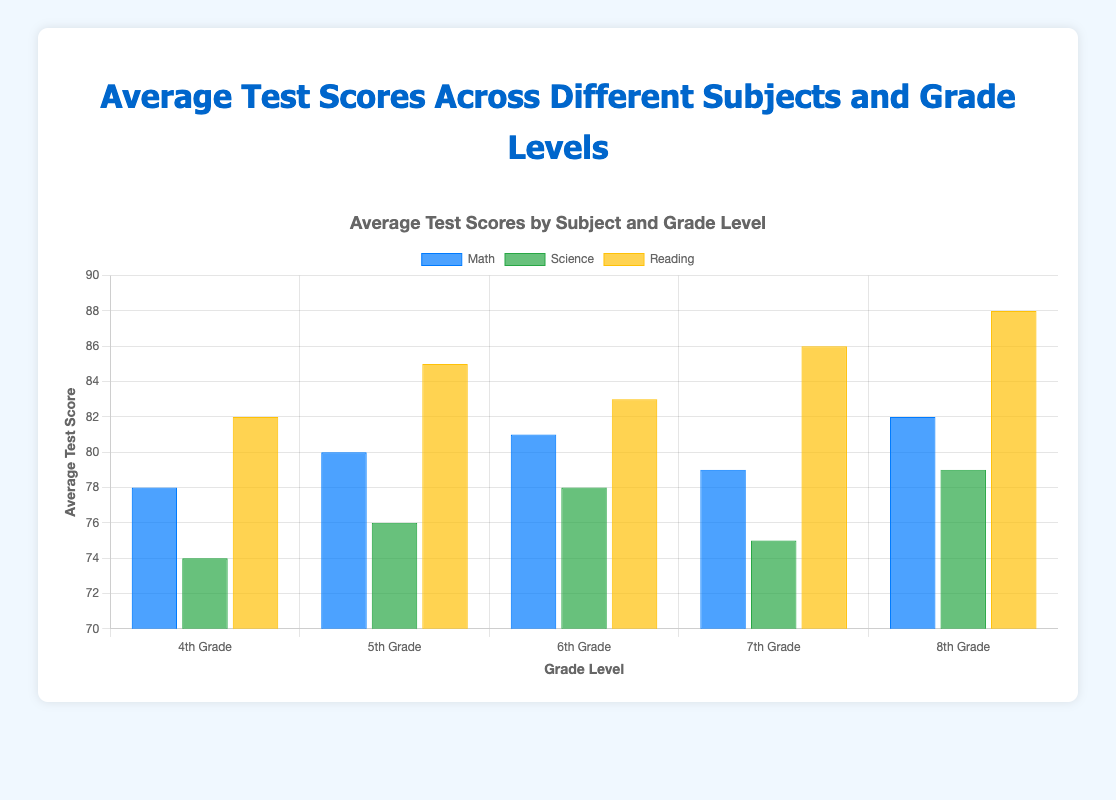What is the highest average test score for 8th Grade? To determine this, we look at the 8th Grade row and compare the scores across Math, Science, and Reading. The scores are Math: 82, Science: 79, and Reading: 88. Therefore, the highest score is from Reading.
Answer: 88 Which grade level has the highest average test score in Reading? To find the highest average test score in Reading, look at the Reading scores across all grades. The scores are 4th Grade: 82, 5th Grade: 85, 6th Grade: 83, 7th Grade: 86, and 8th Grade: 88. The highest score is in 8th Grade.
Answer: 8th Grade What is the difference between the average test scores in Math for 6th Grade and 7th Grade? We compare the Math scores for 6th Grade and 7th Grade. The Math score for 6th Grade is 81, and for 7th Grade it is 79. The difference is calculated as 81 - 79.
Answer: 2 How many grades show an average test score above 80 in Science? We examine the Science scores for each grade. The scores are 4th Grade: 74, 5th Grade: 76, 6th Grade: 78, 7th Grade: 75, and 8th Grade: 79. None of these scores are above 80.
Answer: 0 What is the average test score for Math across all grades? To find this, we sum the Math scores for all grades and divide by the number of grades. The scores are 4th Grade: 78, 5th Grade: 80, 6th Grade: 81, 7th Grade: 79, and 8th Grade: 82. The sum is 78 + 80 + 81 + 79 + 82 = 400. There are 5 grades, so 400 / 5 = 80.
Answer: 80 Which subject has the highest average test score in 4th and 5th Grade combined? First, calculate the average test score for each subject by combining 4th and 5th grades. Math: (78 + 80) / 2 = 79, Science: (74 + 76) / 2 = 75, Reading: (82 + 85) / 2 = 83. The highest average is in Reading.
Answer: Reading 